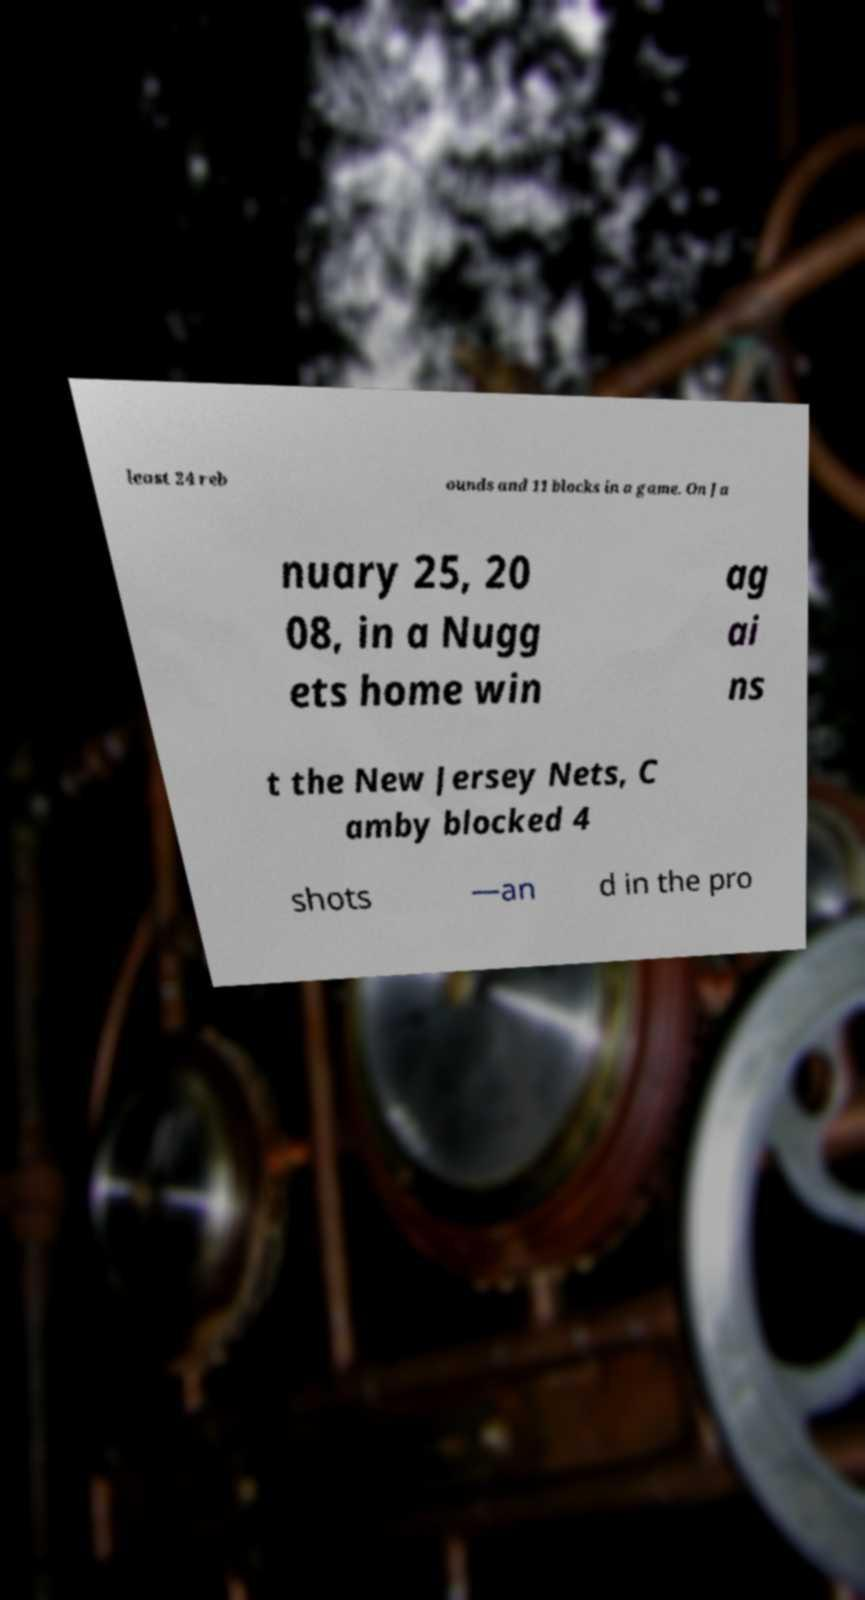Can you accurately transcribe the text from the provided image for me? least 24 reb ounds and 11 blocks in a game. On Ja nuary 25, 20 08, in a Nugg ets home win ag ai ns t the New Jersey Nets, C amby blocked 4 shots —an d in the pro 